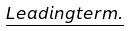<formula> <loc_0><loc_0><loc_500><loc_500>\underline { L e a d i n g t e r m . } & &</formula> 